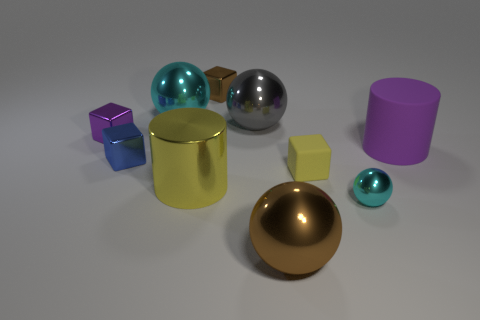Subtract all tiny metallic spheres. How many spheres are left? 3 Subtract all yellow blocks. How many blocks are left? 3 Subtract all balls. How many objects are left? 6 Subtract 2 cylinders. How many cylinders are left? 0 Add 3 brown blocks. How many brown blocks are left? 4 Add 9 small red metal cubes. How many small red metal cubes exist? 9 Subtract 1 gray balls. How many objects are left? 9 Subtract all gray cubes. Subtract all blue cylinders. How many cubes are left? 4 Subtract all purple cylinders. How many brown cubes are left? 1 Subtract all small brown shiny objects. Subtract all tiny brown shiny things. How many objects are left? 8 